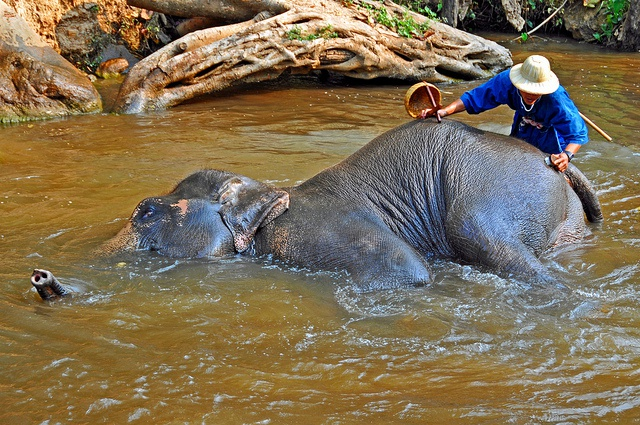Describe the objects in this image and their specific colors. I can see elephant in white, gray, darkgray, and black tones and people in white, black, navy, and darkblue tones in this image. 